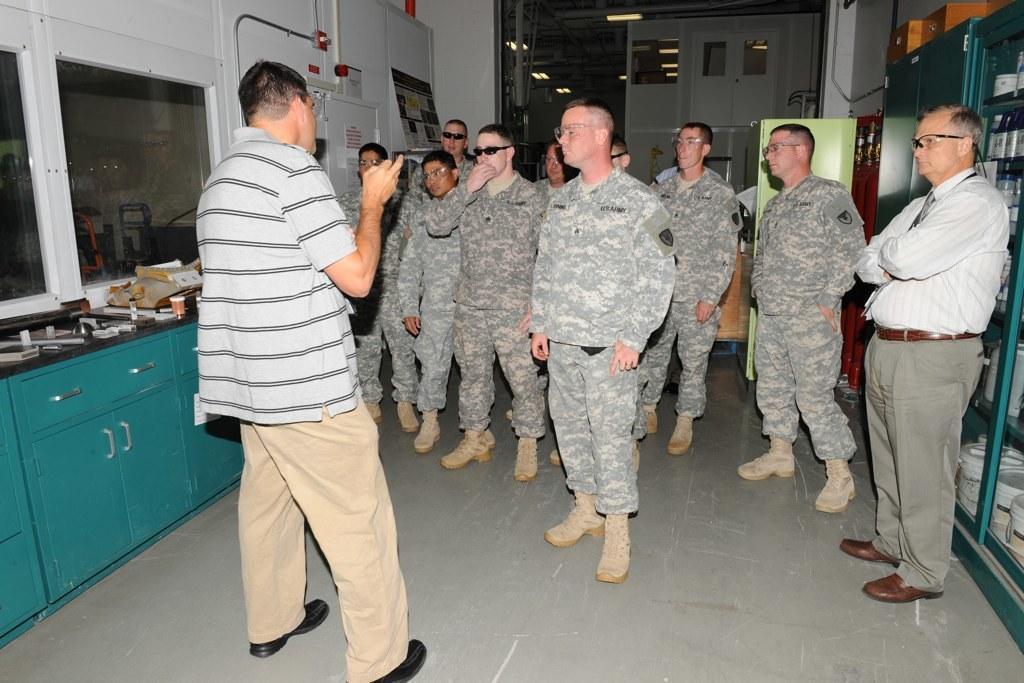Describe this image in one or two sentences. In this image we can see a few people standing on the floor, there are cupboards, in the cupboard we can see some objects and also we can see a table with some objects, at the top we can see the lights and a board with some text and images. 